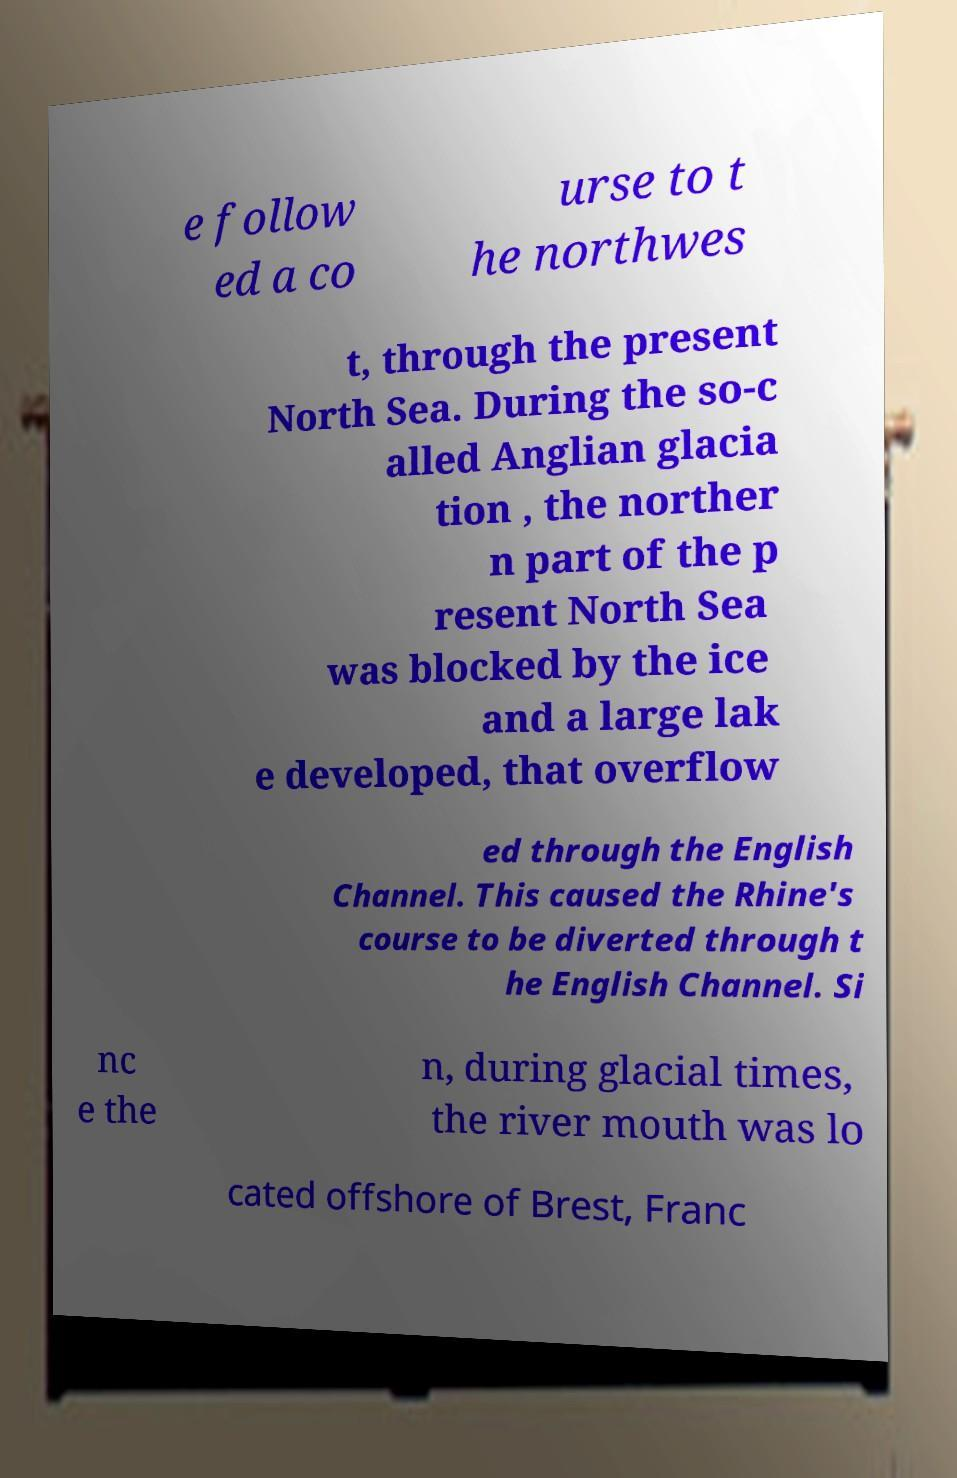Could you extract and type out the text from this image? e follow ed a co urse to t he northwes t, through the present North Sea. During the so-c alled Anglian glacia tion , the norther n part of the p resent North Sea was blocked by the ice and a large lak e developed, that overflow ed through the English Channel. This caused the Rhine's course to be diverted through t he English Channel. Si nc e the n, during glacial times, the river mouth was lo cated offshore of Brest, Franc 